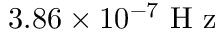Convert formula to latex. <formula><loc_0><loc_0><loc_500><loc_500>3 . 8 6 \times 1 0 ^ { - 7 } H z</formula> 